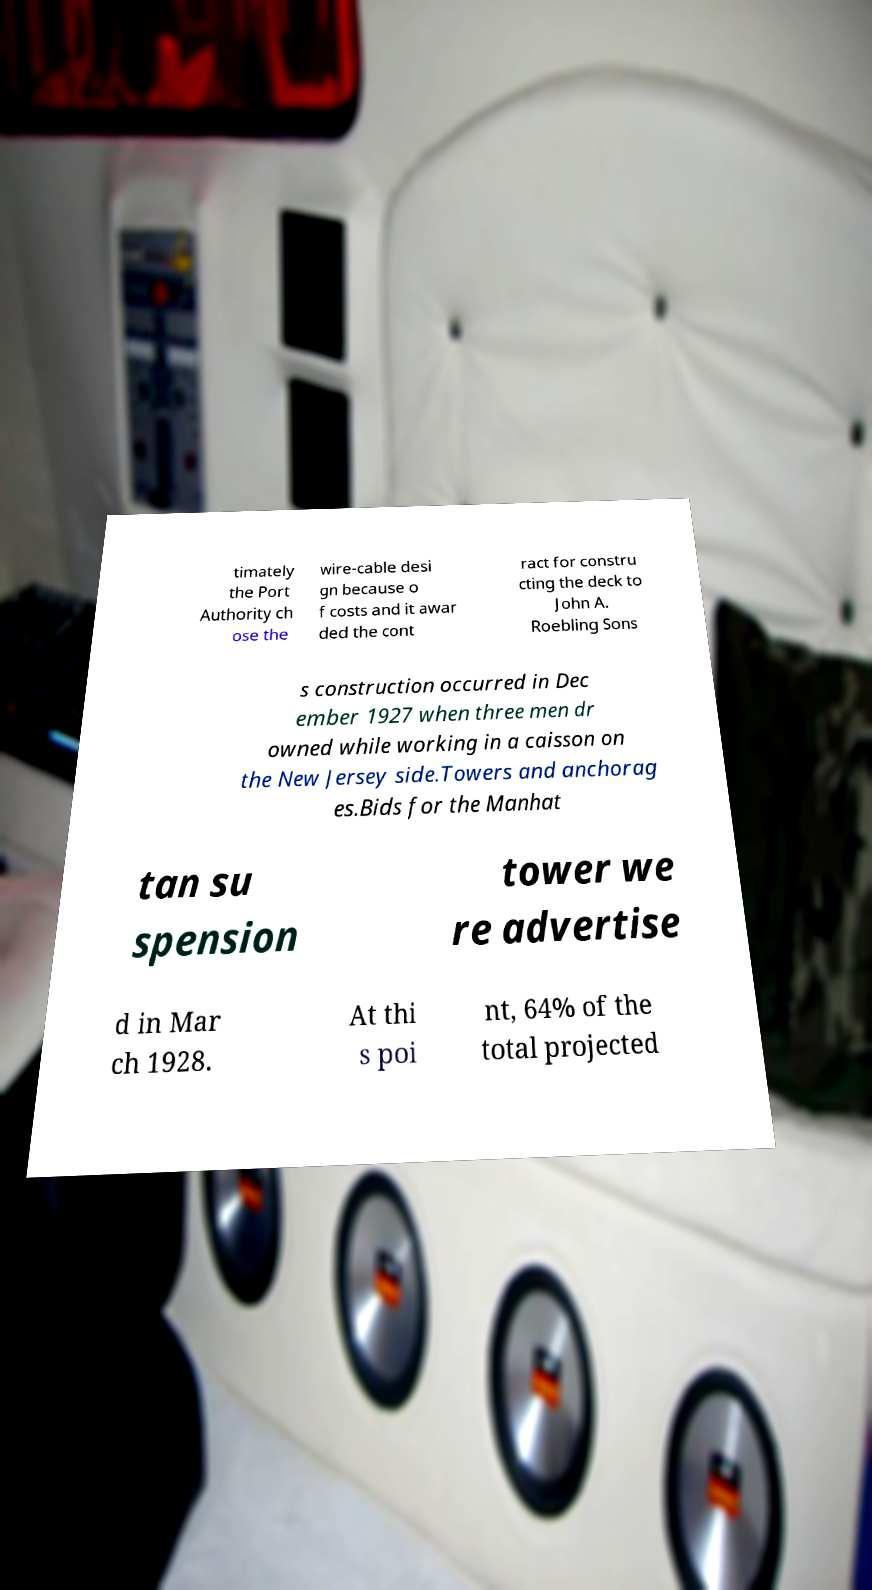I need the written content from this picture converted into text. Can you do that? timately the Port Authority ch ose the wire-cable desi gn because o f costs and it awar ded the cont ract for constru cting the deck to John A. Roebling Sons s construction occurred in Dec ember 1927 when three men dr owned while working in a caisson on the New Jersey side.Towers and anchorag es.Bids for the Manhat tan su spension tower we re advertise d in Mar ch 1928. At thi s poi nt, 64% of the total projected 